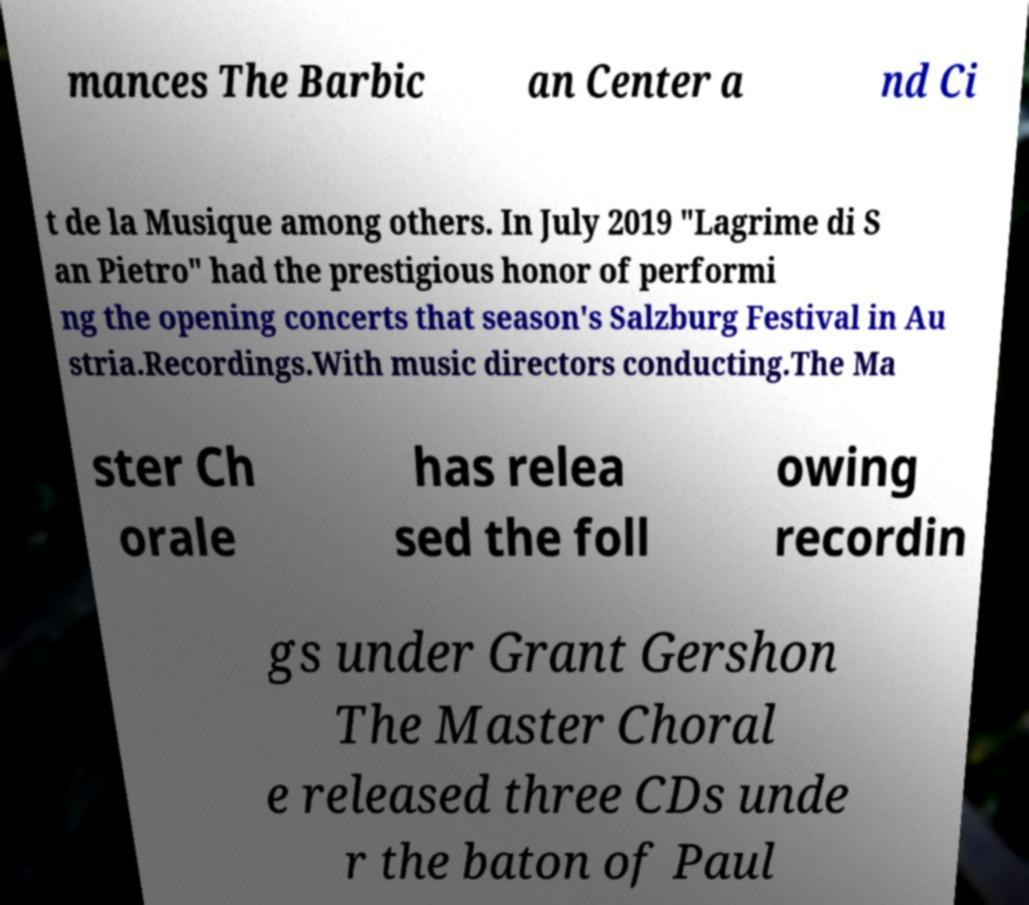Please read and relay the text visible in this image. What does it say? mances The Barbic an Center a nd Ci t de la Musique among others. In July 2019 "Lagrime di S an Pietro" had the prestigious honor of performi ng the opening concerts that season's Salzburg Festival in Au stria.Recordings.With music directors conducting.The Ma ster Ch orale has relea sed the foll owing recordin gs under Grant Gershon The Master Choral e released three CDs unde r the baton of Paul 